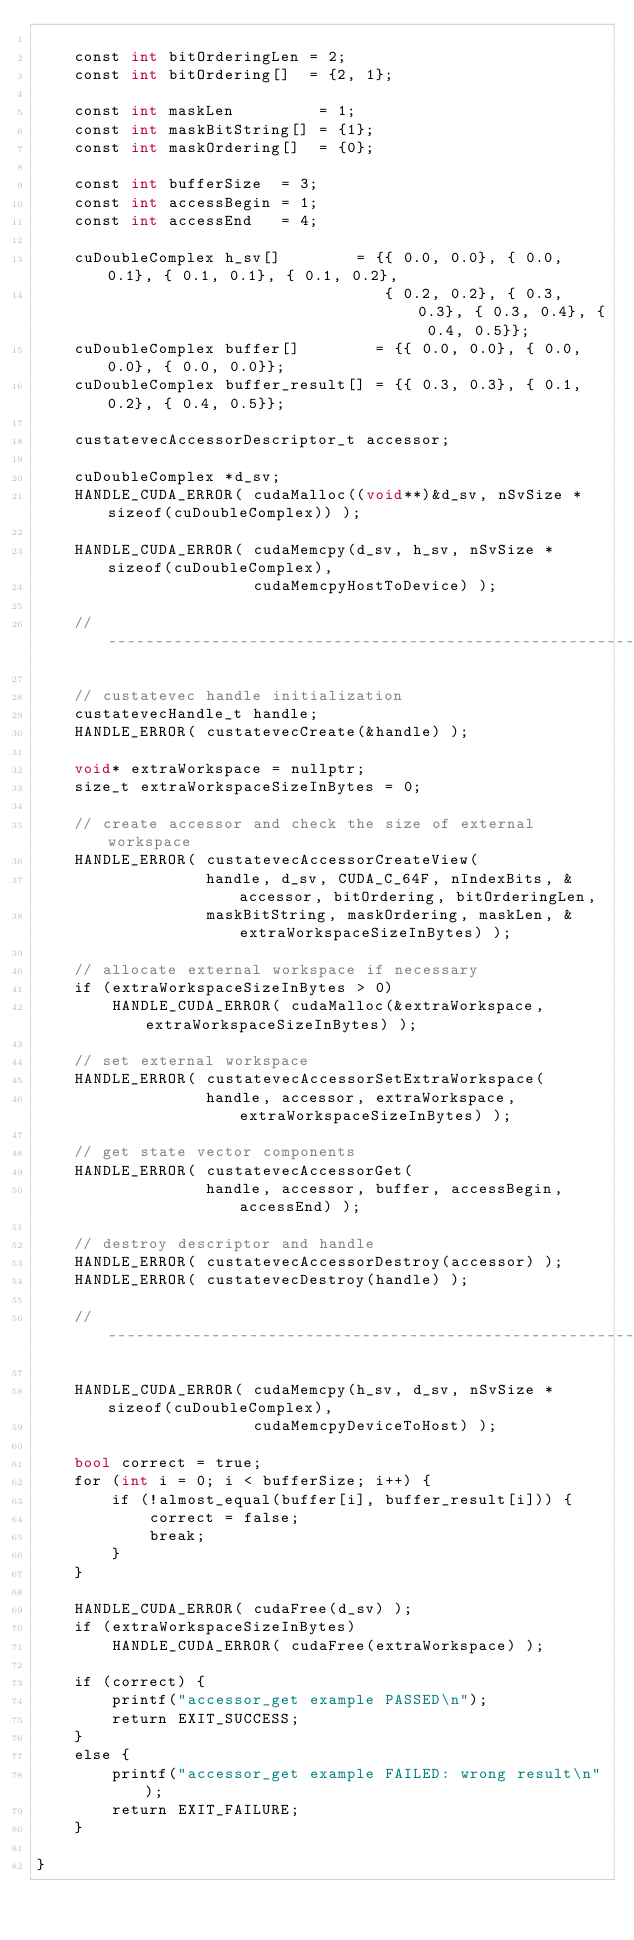Convert code to text. <code><loc_0><loc_0><loc_500><loc_500><_Cuda_>
    const int bitOrderingLen = 2;
    const int bitOrdering[]  = {2, 1};

    const int maskLen         = 1;
    const int maskBitString[] = {1};
    const int maskOrdering[]  = {0};

    const int bufferSize  = 3;
    const int accessBegin = 1;
    const int accessEnd   = 4;

    cuDoubleComplex h_sv[]        = {{ 0.0, 0.0}, { 0.0, 0.1}, { 0.1, 0.1}, { 0.1, 0.2},
                                     { 0.2, 0.2}, { 0.3, 0.3}, { 0.3, 0.4}, { 0.4, 0.5}};
    cuDoubleComplex buffer[]        = {{ 0.0, 0.0}, { 0.0, 0.0}, { 0.0, 0.0}};
    cuDoubleComplex buffer_result[] = {{ 0.3, 0.3}, { 0.1, 0.2}, { 0.4, 0.5}};

    custatevecAccessorDescriptor_t accessor;

    cuDoubleComplex *d_sv;
    HANDLE_CUDA_ERROR( cudaMalloc((void**)&d_sv, nSvSize * sizeof(cuDoubleComplex)) );

    HANDLE_CUDA_ERROR( cudaMemcpy(d_sv, h_sv, nSvSize * sizeof(cuDoubleComplex),
                       cudaMemcpyHostToDevice) );

    //----------------------------------------------------------------------------------------------

    // custatevec handle initialization
    custatevecHandle_t handle;
    HANDLE_ERROR( custatevecCreate(&handle) );

    void* extraWorkspace = nullptr;
    size_t extraWorkspaceSizeInBytes = 0;

    // create accessor and check the size of external workspace
    HANDLE_ERROR( custatevecAccessorCreateView(
                  handle, d_sv, CUDA_C_64F, nIndexBits, &accessor, bitOrdering, bitOrderingLen,
                  maskBitString, maskOrdering, maskLen, &extraWorkspaceSizeInBytes) );

    // allocate external workspace if necessary
    if (extraWorkspaceSizeInBytes > 0)
        HANDLE_CUDA_ERROR( cudaMalloc(&extraWorkspace, extraWorkspaceSizeInBytes) );

    // set external workspace
    HANDLE_ERROR( custatevecAccessorSetExtraWorkspace(
                  handle, accessor, extraWorkspace, extraWorkspaceSizeInBytes) );

    // get state vector components
    HANDLE_ERROR( custatevecAccessorGet(
                  handle, accessor, buffer, accessBegin, accessEnd) );

    // destroy descriptor and handle
    HANDLE_ERROR( custatevecAccessorDestroy(accessor) );
    HANDLE_ERROR( custatevecDestroy(handle) );

    //----------------------------------------------------------------------------------------------

    HANDLE_CUDA_ERROR( cudaMemcpy(h_sv, d_sv, nSvSize * sizeof(cuDoubleComplex),
                       cudaMemcpyDeviceToHost) );

    bool correct = true;
    for (int i = 0; i < bufferSize; i++) {
        if (!almost_equal(buffer[i], buffer_result[i])) {
            correct = false;
            break;
        }
    }

    HANDLE_CUDA_ERROR( cudaFree(d_sv) );
    if (extraWorkspaceSizeInBytes)
        HANDLE_CUDA_ERROR( cudaFree(extraWorkspace) );

    if (correct) {
        printf("accessor_get example PASSED\n");
        return EXIT_SUCCESS;
    }
    else {
        printf("accessor_get example FAILED: wrong result\n");
        return EXIT_FAILURE;
    }

}
</code> 